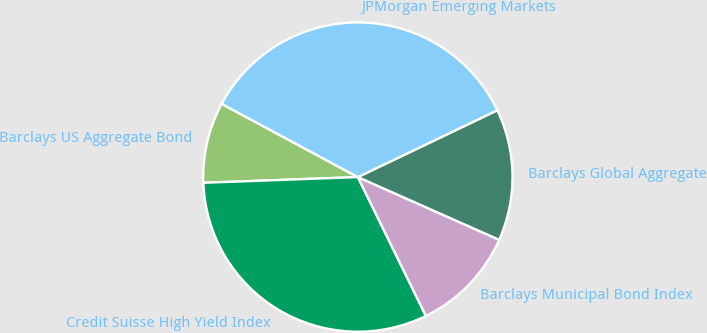Convert chart to OTSL. <chart><loc_0><loc_0><loc_500><loc_500><pie_chart><fcel>Barclays US Aggregate Bond<fcel>Credit Suisse High Yield Index<fcel>Barclays Municipal Bond Index<fcel>Barclays Global Aggregate<fcel>JPMorgan Emerging Markets<nl><fcel>8.44%<fcel>31.66%<fcel>11.1%<fcel>13.76%<fcel>35.04%<nl></chart> 